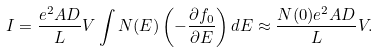Convert formula to latex. <formula><loc_0><loc_0><loc_500><loc_500>I = \frac { e ^ { 2 } A D } { L } V \int N ( E ) \left ( - \frac { \partial f _ { 0 } } { \partial E } \right ) d E \approx \frac { N ( 0 ) e ^ { 2 } A D } { L } V .</formula> 